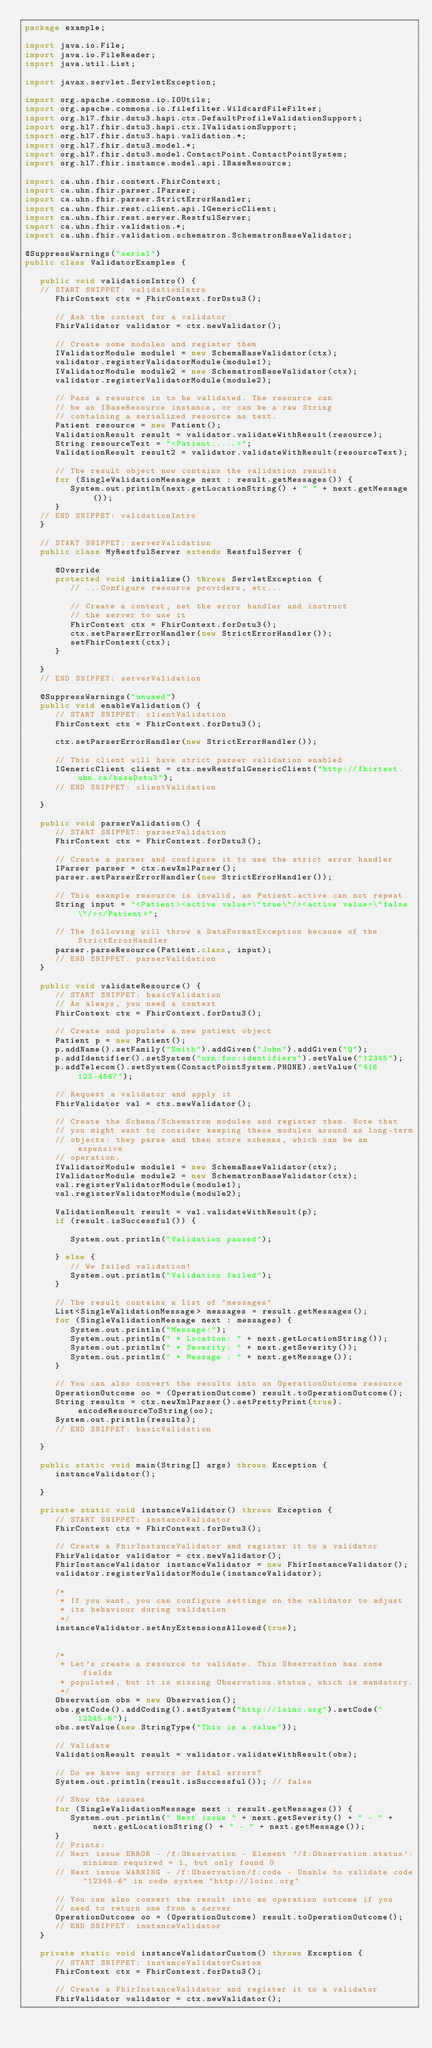Convert code to text. <code><loc_0><loc_0><loc_500><loc_500><_Java_>package example;

import java.io.File;
import java.io.FileReader;
import java.util.List;

import javax.servlet.ServletException;

import org.apache.commons.io.IOUtils;
import org.apache.commons.io.filefilter.WildcardFileFilter;
import org.hl7.fhir.dstu3.hapi.ctx.DefaultProfileValidationSupport;
import org.hl7.fhir.dstu3.hapi.ctx.IValidationSupport;
import org.hl7.fhir.dstu3.hapi.validation.*;
import org.hl7.fhir.dstu3.model.*;
import org.hl7.fhir.dstu3.model.ContactPoint.ContactPointSystem;
import org.hl7.fhir.instance.model.api.IBaseResource;

import ca.uhn.fhir.context.FhirContext;
import ca.uhn.fhir.parser.IParser;
import ca.uhn.fhir.parser.StrictErrorHandler;
import ca.uhn.fhir.rest.client.api.IGenericClient;
import ca.uhn.fhir.rest.server.RestfulServer;
import ca.uhn.fhir.validation.*;
import ca.uhn.fhir.validation.schematron.SchematronBaseValidator;

@SuppressWarnings("serial")
public class ValidatorExamples {

   public void validationIntro() {
   // START SNIPPET: validationIntro
      FhirContext ctx = FhirContext.forDstu3();
      
      // Ask the context for a validator
      FhirValidator validator = ctx.newValidator();
      
      // Create some modules and register them 
      IValidatorModule module1 = new SchemaBaseValidator(ctx);
      validator.registerValidatorModule(module1);
      IValidatorModule module2 = new SchematronBaseValidator(ctx);
      validator.registerValidatorModule(module2);
      
      // Pass a resource in to be validated. The resource can
      // be an IBaseResource instance, or can be a raw String
      // containing a serialized resource as text.
      Patient resource = new Patient();
      ValidationResult result = validator.validateWithResult(resource);
      String resourceText = "<Patient.....>";
      ValidationResult result2 = validator.validateWithResult(resourceText);
      
      // The result object now contains the validation results
      for (SingleValidationMessage next : result.getMessages()) {
         System.out.println(next.getLocationString() + " " + next.getMessage());
      }
   // END SNIPPET: validationIntro
   }
   
   // START SNIPPET: serverValidation
   public class MyRestfulServer extends RestfulServer {

      @Override
      protected void initialize() throws ServletException {
         // ...Configure resource providers, etc... 
         
         // Create a context, set the error handler and instruct
         // the server to use it
         FhirContext ctx = FhirContext.forDstu3();
         ctx.setParserErrorHandler(new StrictErrorHandler());
         setFhirContext(ctx);
      }
      
   }
   // END SNIPPET: serverValidation

   @SuppressWarnings("unused")
   public void enableValidation() {
      // START SNIPPET: clientValidation
      FhirContext ctx = FhirContext.forDstu3();
      
      ctx.setParserErrorHandler(new StrictErrorHandler());
      
      // This client will have strict parser validation enabled
      IGenericClient client = ctx.newRestfulGenericClient("http://fhirtest.uhn.ca/baseDstu3");
      // END SNIPPET: clientValidation
      
   }
   
   public void parserValidation() {
      // START SNIPPET: parserValidation
      FhirContext ctx = FhirContext.forDstu3();
      
      // Create a parser and configure it to use the strict error handler
      IParser parser = ctx.newXmlParser();
      parser.setParserErrorHandler(new StrictErrorHandler());

      // This example resource is invalid, as Patient.active can not repeat
      String input = "<Patient><active value=\"true\"/><active value=\"false\"/></Patient>";

      // The following will throw a DataFormatException because of the StrictErrorHandler
      parser.parseResource(Patient.class, input);
      // END SNIPPET: parserValidation
   }

   public void validateResource() {
      // START SNIPPET: basicValidation
      // As always, you need a context
      FhirContext ctx = FhirContext.forDstu3();

      // Create and populate a new patient object
      Patient p = new Patient();
      p.addName().setFamily("Smith").addGiven("John").addGiven("Q");
      p.addIdentifier().setSystem("urn:foo:identifiers").setValue("12345");
      p.addTelecom().setSystem(ContactPointSystem.PHONE).setValue("416 123-4567");

      // Request a validator and apply it
      FhirValidator val = ctx.newValidator();

      // Create the Schema/Schematron modules and register them. Note that
      // you might want to consider keeping these modules around as long-term
      // objects: they parse and then store schemas, which can be an expensive
      // operation.
      IValidatorModule module1 = new SchemaBaseValidator(ctx);
      IValidatorModule module2 = new SchematronBaseValidator(ctx);
      val.registerValidatorModule(module1);
      val.registerValidatorModule(module2);

      ValidationResult result = val.validateWithResult(p);
      if (result.isSuccessful()) {
         
         System.out.println("Validation passed");
         
      } else {
         // We failed validation!
         System.out.println("Validation failed");
      }
      
      // The result contains a list of "messages" 
      List<SingleValidationMessage> messages = result.getMessages();
      for (SingleValidationMessage next : messages) {
         System.out.println("Message:");
         System.out.println(" * Location: " + next.getLocationString());
         System.out.println(" * Severity: " + next.getSeverity());
         System.out.println(" * Message : " + next.getMessage());
      }
      
      // You can also convert the results into an OperationOutcome resource
      OperationOutcome oo = (OperationOutcome) result.toOperationOutcome();
      String results = ctx.newXmlParser().setPrettyPrint(true).encodeResourceToString(oo);
      System.out.println(results);
      // END SNIPPET: basicValidation

   }

   public static void main(String[] args) throws Exception {
      instanceValidator();

   }

   private static void instanceValidator() throws Exception {
      // START SNIPPET: instanceValidator
      FhirContext ctx = FhirContext.forDstu3();

      // Create a FhirInstanceValidator and register it to a validator
      FhirValidator validator = ctx.newValidator();
      FhirInstanceValidator instanceValidator = new FhirInstanceValidator();
      validator.registerValidatorModule(instanceValidator);
      
      /*
       * If you want, you can configure settings on the validator to adjust
       * its behaviour during validation
       */
      instanceValidator.setAnyExtensionsAllowed(true);
      
      
      /*
       * Let's create a resource to validate. This Observation has some fields
       * populated, but it is missing Observation.status, which is mandatory.
       */
      Observation obs = new Observation();
      obs.getCode().addCoding().setSystem("http://loinc.org").setCode("12345-6");
      obs.setValue(new StringType("This is a value"));
      
      // Validate
      ValidationResult result = validator.validateWithResult(obs);
      
      // Do we have any errors or fatal errors?
      System.out.println(result.isSuccessful()); // false
      
      // Show the issues
      for (SingleValidationMessage next : result.getMessages()) {
         System.out.println(" Next issue " + next.getSeverity() + " - " + next.getLocationString() + " - " + next.getMessage());
      }
      // Prints:
      // Next issue ERROR - /f:Observation - Element '/f:Observation.status': minimum required = 1, but only found 0
      // Next issue WARNING - /f:Observation/f:code - Unable to validate code "12345-6" in code system "http://loinc.org"
      
      // You can also convert the result into an operation outcome if you 
      // need to return one from a server
      OperationOutcome oo = (OperationOutcome) result.toOperationOutcome();
      // END SNIPPET: instanceValidator
   }
   
   private static void instanceValidatorCustom() throws Exception {
      // START SNIPPET: instanceValidatorCustom
      FhirContext ctx = FhirContext.forDstu3();

      // Create a FhirInstanceValidator and register it to a validator
      FhirValidator validator = ctx.newValidator();</code> 